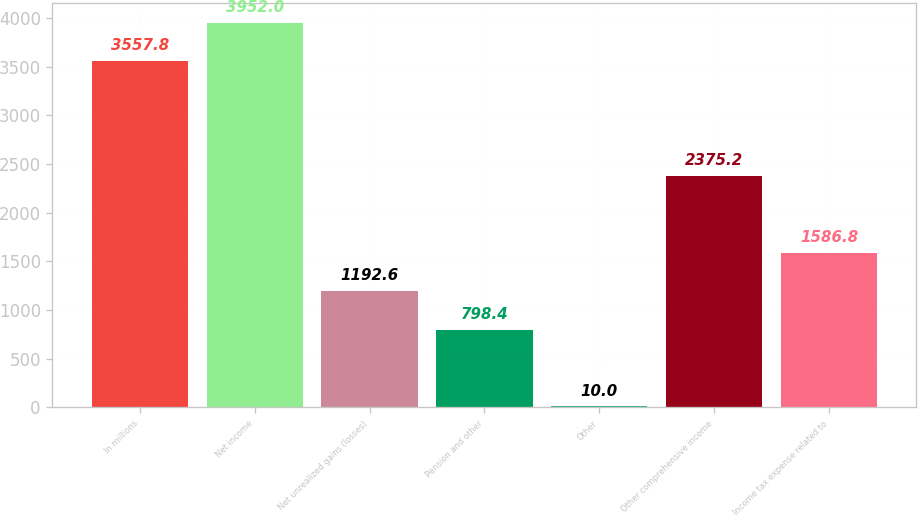Convert chart. <chart><loc_0><loc_0><loc_500><loc_500><bar_chart><fcel>In millions<fcel>Net income<fcel>Net unrealized gains (losses)<fcel>Pension and other<fcel>Other<fcel>Other comprehensive income<fcel>Income tax expense related to<nl><fcel>3557.8<fcel>3952<fcel>1192.6<fcel>798.4<fcel>10<fcel>2375.2<fcel>1586.8<nl></chart> 